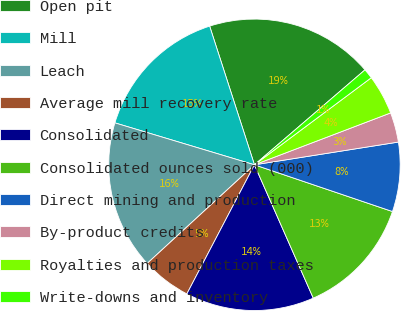Convert chart. <chart><loc_0><loc_0><loc_500><loc_500><pie_chart><fcel>Open pit<fcel>Mill<fcel>Leach<fcel>Average mill recovery rate<fcel>Consolidated<fcel>Consolidated ounces sold (000)<fcel>Direct mining and production<fcel>By-product credits<fcel>Royalties and production taxes<fcel>Write-downs and inventory<nl><fcel>18.68%<fcel>15.38%<fcel>16.48%<fcel>5.49%<fcel>14.29%<fcel>13.19%<fcel>7.69%<fcel>3.3%<fcel>4.4%<fcel>1.1%<nl></chart> 